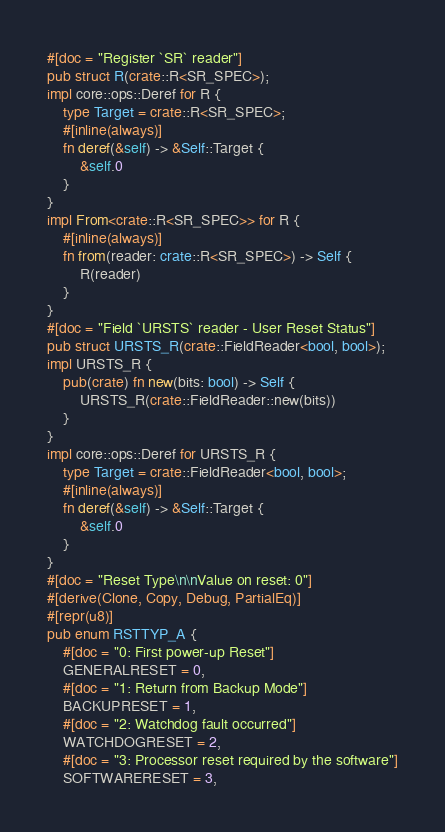Convert code to text. <code><loc_0><loc_0><loc_500><loc_500><_Rust_>#[doc = "Register `SR` reader"]
pub struct R(crate::R<SR_SPEC>);
impl core::ops::Deref for R {
    type Target = crate::R<SR_SPEC>;
    #[inline(always)]
    fn deref(&self) -> &Self::Target {
        &self.0
    }
}
impl From<crate::R<SR_SPEC>> for R {
    #[inline(always)]
    fn from(reader: crate::R<SR_SPEC>) -> Self {
        R(reader)
    }
}
#[doc = "Field `URSTS` reader - User Reset Status"]
pub struct URSTS_R(crate::FieldReader<bool, bool>);
impl URSTS_R {
    pub(crate) fn new(bits: bool) -> Self {
        URSTS_R(crate::FieldReader::new(bits))
    }
}
impl core::ops::Deref for URSTS_R {
    type Target = crate::FieldReader<bool, bool>;
    #[inline(always)]
    fn deref(&self) -> &Self::Target {
        &self.0
    }
}
#[doc = "Reset Type\n\nValue on reset: 0"]
#[derive(Clone, Copy, Debug, PartialEq)]
#[repr(u8)]
pub enum RSTTYP_A {
    #[doc = "0: First power-up Reset"]
    GENERALRESET = 0,
    #[doc = "1: Return from Backup Mode"]
    BACKUPRESET = 1,
    #[doc = "2: Watchdog fault occurred"]
    WATCHDOGRESET = 2,
    #[doc = "3: Processor reset required by the software"]
    SOFTWARERESET = 3,</code> 